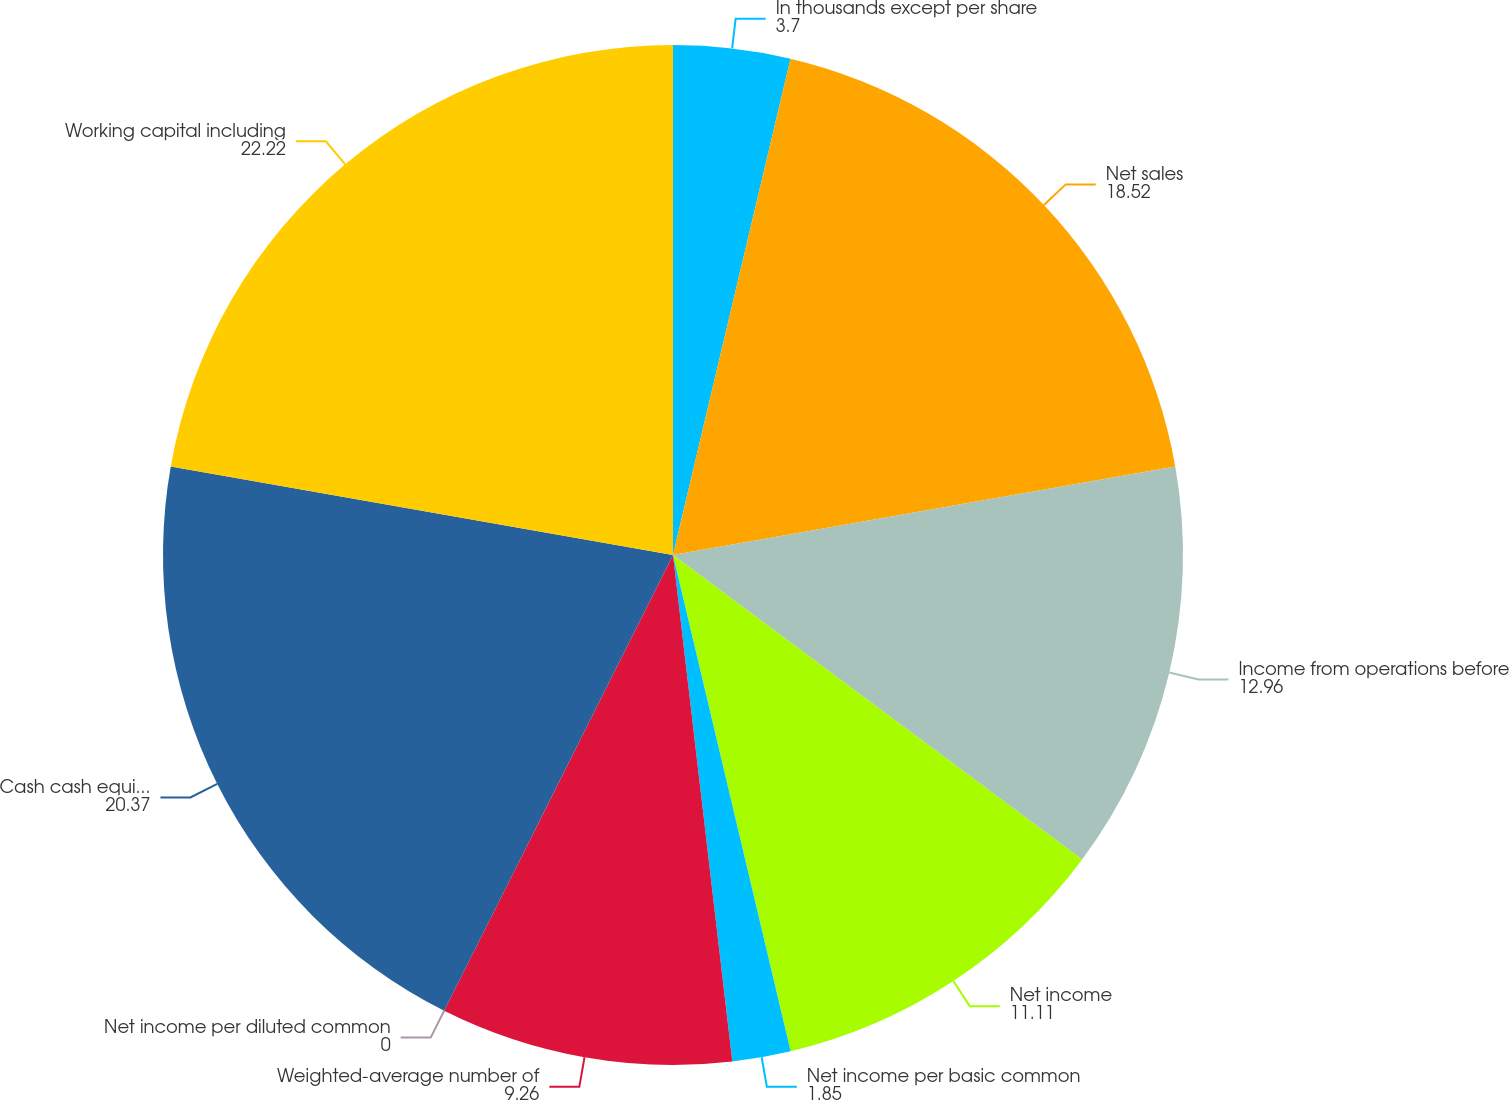<chart> <loc_0><loc_0><loc_500><loc_500><pie_chart><fcel>In thousands except per share<fcel>Net sales<fcel>Income from operations before<fcel>Net income<fcel>Net income per basic common<fcel>Weighted-average number of<fcel>Net income per diluted common<fcel>Cash cash equivalents and<fcel>Working capital including<nl><fcel>3.7%<fcel>18.52%<fcel>12.96%<fcel>11.11%<fcel>1.85%<fcel>9.26%<fcel>0.0%<fcel>20.37%<fcel>22.22%<nl></chart> 